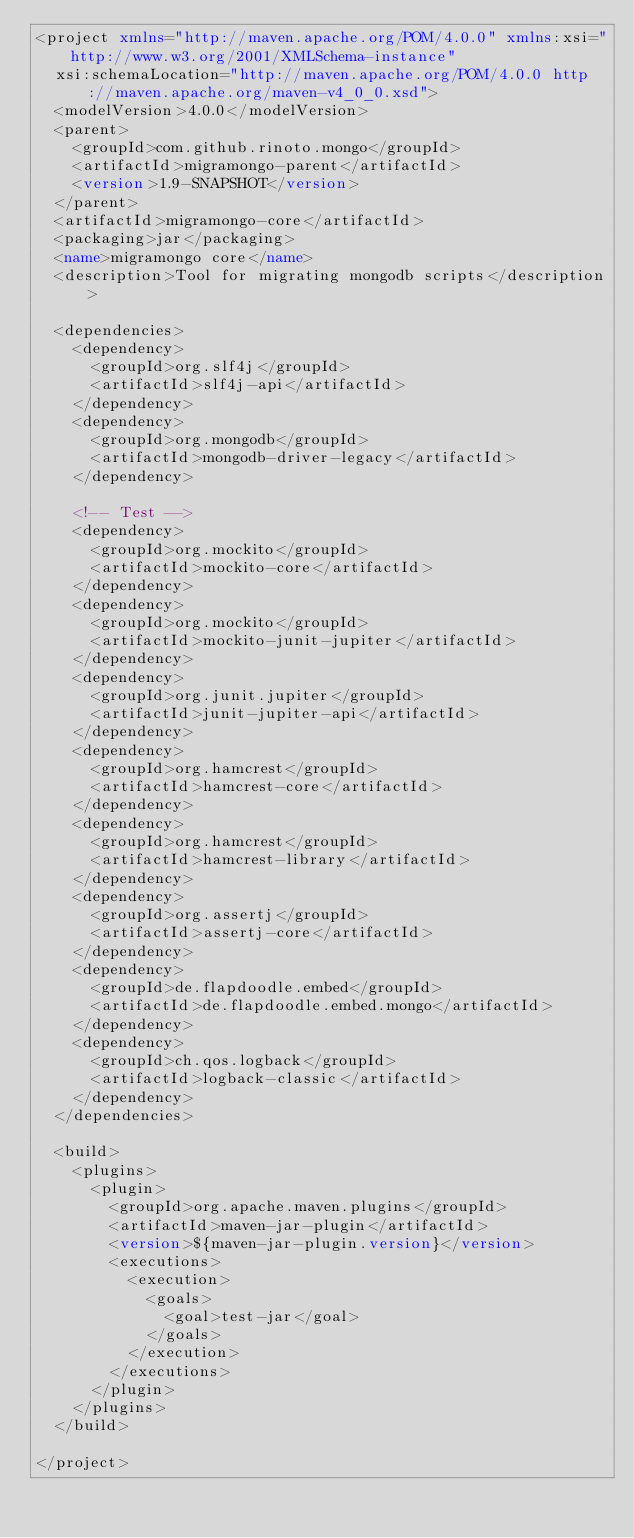Convert code to text. <code><loc_0><loc_0><loc_500><loc_500><_XML_><project xmlns="http://maven.apache.org/POM/4.0.0" xmlns:xsi="http://www.w3.org/2001/XMLSchema-instance"
	xsi:schemaLocation="http://maven.apache.org/POM/4.0.0 http://maven.apache.org/maven-v4_0_0.xsd">
	<modelVersion>4.0.0</modelVersion>
	<parent>
		<groupId>com.github.rinoto.mongo</groupId>
		<artifactId>migramongo-parent</artifactId>
		<version>1.9-SNAPSHOT</version>
	</parent>
	<artifactId>migramongo-core</artifactId>
	<packaging>jar</packaging>
	<name>migramongo core</name>
	<description>Tool for migrating mongodb scripts</description>

	<dependencies>
		<dependency>
			<groupId>org.slf4j</groupId>
			<artifactId>slf4j-api</artifactId>
		</dependency>
		<dependency>
			<groupId>org.mongodb</groupId>
			<artifactId>mongodb-driver-legacy</artifactId>
		</dependency>

		<!-- Test -->
		<dependency>
			<groupId>org.mockito</groupId>
			<artifactId>mockito-core</artifactId>
		</dependency>
		<dependency>
			<groupId>org.mockito</groupId>
			<artifactId>mockito-junit-jupiter</artifactId>
		</dependency>
		<dependency>
			<groupId>org.junit.jupiter</groupId>
			<artifactId>junit-jupiter-api</artifactId>
		</dependency>
		<dependency>
			<groupId>org.hamcrest</groupId>
			<artifactId>hamcrest-core</artifactId>
		</dependency>
		<dependency>
			<groupId>org.hamcrest</groupId>
			<artifactId>hamcrest-library</artifactId>
		</dependency>
		<dependency>
			<groupId>org.assertj</groupId>
			<artifactId>assertj-core</artifactId>
		</dependency>
		<dependency>
			<groupId>de.flapdoodle.embed</groupId>
			<artifactId>de.flapdoodle.embed.mongo</artifactId>
		</dependency>
		<dependency>
			<groupId>ch.qos.logback</groupId>
			<artifactId>logback-classic</artifactId>
		</dependency>
	</dependencies>

	<build>
		<plugins>
			<plugin>
				<groupId>org.apache.maven.plugins</groupId>
				<artifactId>maven-jar-plugin</artifactId>
				<version>${maven-jar-plugin.version}</version>
				<executions>
					<execution>
						<goals>
							<goal>test-jar</goal>
						</goals>
					</execution>
				</executions>
			</plugin>
		</plugins>
	</build>

</project>

</code> 